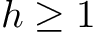<formula> <loc_0><loc_0><loc_500><loc_500>h \geq 1</formula> 